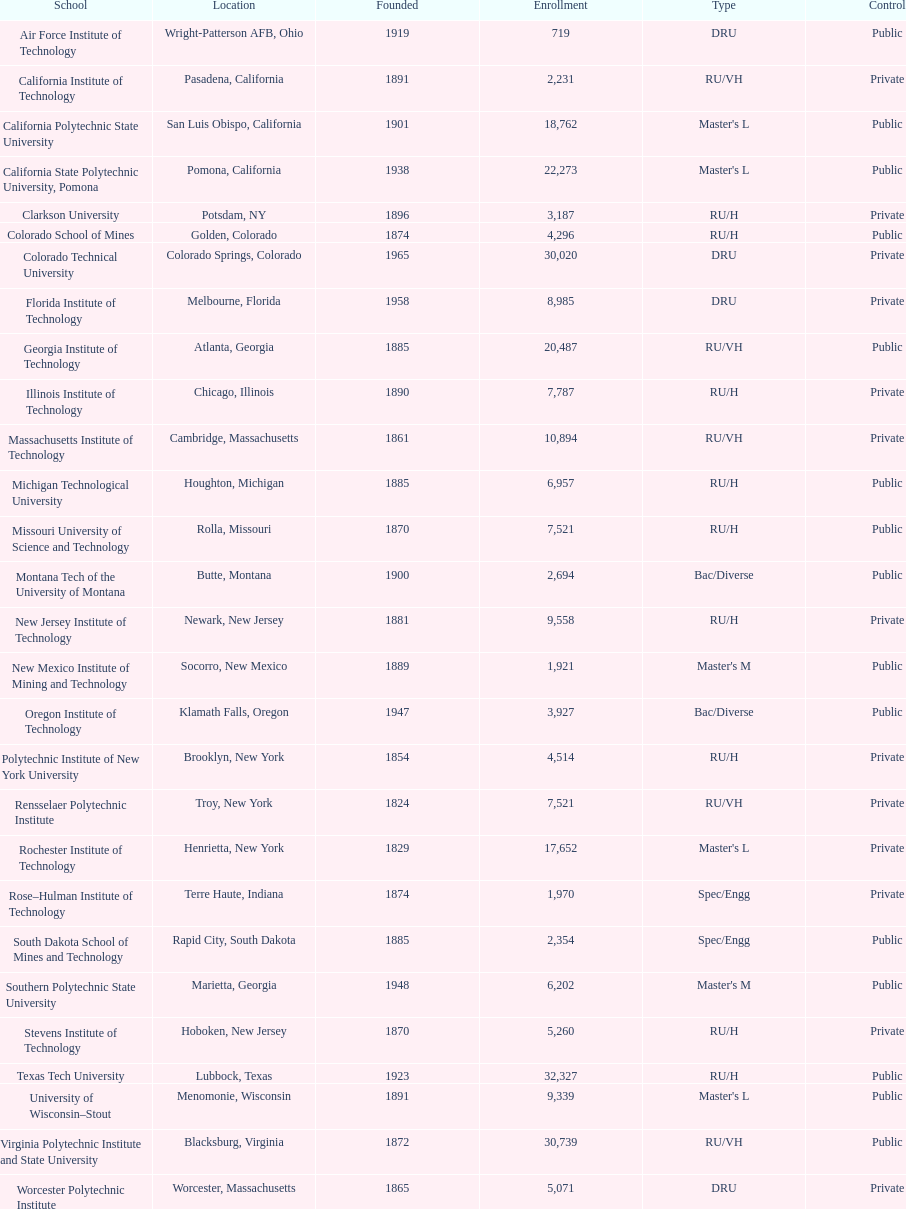What is the difference in enrollment between the top 2 schools listed in the table? 1512. I'm looking to parse the entire table for insights. Could you assist me with that? {'header': ['School', 'Location', 'Founded', 'Enrollment', 'Type', 'Control'], 'rows': [['Air Force Institute of Technology', 'Wright-Patterson AFB, Ohio', '1919', '719', 'DRU', 'Public'], ['California Institute of Technology', 'Pasadena, California', '1891', '2,231', 'RU/VH', 'Private'], ['California Polytechnic State University', 'San Luis Obispo, California', '1901', '18,762', "Master's L", 'Public'], ['California State Polytechnic University, Pomona', 'Pomona, California', '1938', '22,273', "Master's L", 'Public'], ['Clarkson University', 'Potsdam, NY', '1896', '3,187', 'RU/H', 'Private'], ['Colorado School of Mines', 'Golden, Colorado', '1874', '4,296', 'RU/H', 'Public'], ['Colorado Technical University', 'Colorado Springs, Colorado', '1965', '30,020', 'DRU', 'Private'], ['Florida Institute of Technology', 'Melbourne, Florida', '1958', '8,985', 'DRU', 'Private'], ['Georgia Institute of Technology', 'Atlanta, Georgia', '1885', '20,487', 'RU/VH', 'Public'], ['Illinois Institute of Technology', 'Chicago, Illinois', '1890', '7,787', 'RU/H', 'Private'], ['Massachusetts Institute of Technology', 'Cambridge, Massachusetts', '1861', '10,894', 'RU/VH', 'Private'], ['Michigan Technological University', 'Houghton, Michigan', '1885', '6,957', 'RU/H', 'Public'], ['Missouri University of Science and Technology', 'Rolla, Missouri', '1870', '7,521', 'RU/H', 'Public'], ['Montana Tech of the University of Montana', 'Butte, Montana', '1900', '2,694', 'Bac/Diverse', 'Public'], ['New Jersey Institute of Technology', 'Newark, New Jersey', '1881', '9,558', 'RU/H', 'Private'], ['New Mexico Institute of Mining and Technology', 'Socorro, New Mexico', '1889', '1,921', "Master's M", 'Public'], ['Oregon Institute of Technology', 'Klamath Falls, Oregon', '1947', '3,927', 'Bac/Diverse', 'Public'], ['Polytechnic Institute of New York University', 'Brooklyn, New York', '1854', '4,514', 'RU/H', 'Private'], ['Rensselaer Polytechnic Institute', 'Troy, New York', '1824', '7,521', 'RU/VH', 'Private'], ['Rochester Institute of Technology', 'Henrietta, New York', '1829', '17,652', "Master's L", 'Private'], ['Rose–Hulman Institute of Technology', 'Terre Haute, Indiana', '1874', '1,970', 'Spec/Engg', 'Private'], ['South Dakota School of Mines and Technology', 'Rapid City, South Dakota', '1885', '2,354', 'Spec/Engg', 'Public'], ['Southern Polytechnic State University', 'Marietta, Georgia', '1948', '6,202', "Master's M", 'Public'], ['Stevens Institute of Technology', 'Hoboken, New Jersey', '1870', '5,260', 'RU/H', 'Private'], ['Texas Tech University', 'Lubbock, Texas', '1923', '32,327', 'RU/H', 'Public'], ['University of Wisconsin–Stout', 'Menomonie, Wisconsin', '1891', '9,339', "Master's L", 'Public'], ['Virginia Polytechnic Institute and State University', 'Blacksburg, Virginia', '1872', '30,739', 'RU/VH', 'Public'], ['Worcester Polytechnic Institute', 'Worcester, Massachusetts', '1865', '5,071', 'DRU', 'Private']]} 